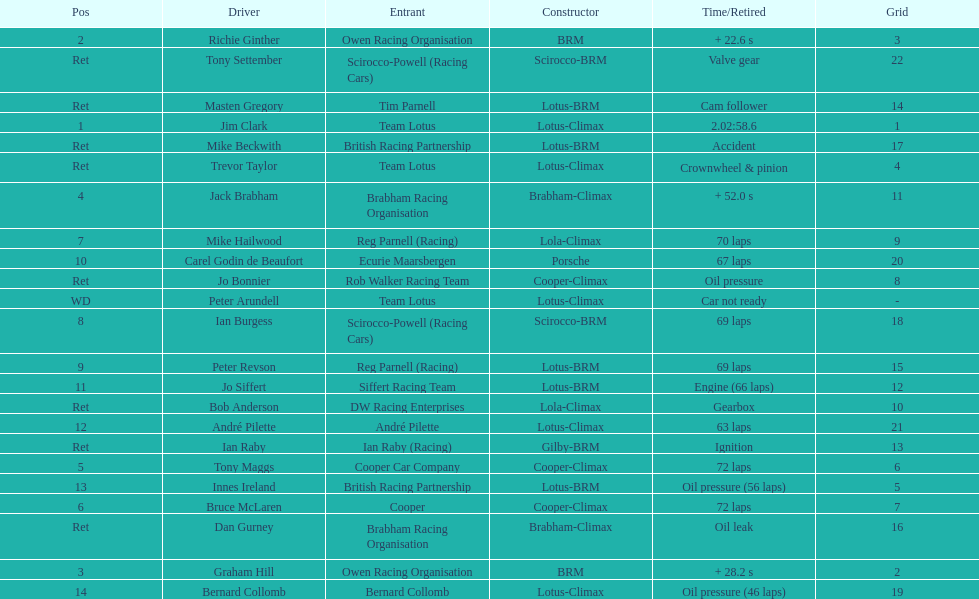Give me the full table as a dictionary. {'header': ['Pos', 'Driver', 'Entrant', 'Constructor', 'Time/Retired', 'Grid'], 'rows': [['2', 'Richie Ginther', 'Owen Racing Organisation', 'BRM', '+ 22.6 s', '3'], ['Ret', 'Tony Settember', 'Scirocco-Powell (Racing Cars)', 'Scirocco-BRM', 'Valve gear', '22'], ['Ret', 'Masten Gregory', 'Tim Parnell', 'Lotus-BRM', 'Cam follower', '14'], ['1', 'Jim Clark', 'Team Lotus', 'Lotus-Climax', '2.02:58.6', '1'], ['Ret', 'Mike Beckwith', 'British Racing Partnership', 'Lotus-BRM', 'Accident', '17'], ['Ret', 'Trevor Taylor', 'Team Lotus', 'Lotus-Climax', 'Crownwheel & pinion', '4'], ['4', 'Jack Brabham', 'Brabham Racing Organisation', 'Brabham-Climax', '+ 52.0 s', '11'], ['7', 'Mike Hailwood', 'Reg Parnell (Racing)', 'Lola-Climax', '70 laps', '9'], ['10', 'Carel Godin de Beaufort', 'Ecurie Maarsbergen', 'Porsche', '67 laps', '20'], ['Ret', 'Jo Bonnier', 'Rob Walker Racing Team', 'Cooper-Climax', 'Oil pressure', '8'], ['WD', 'Peter Arundell', 'Team Lotus', 'Lotus-Climax', 'Car not ready', '-'], ['8', 'Ian Burgess', 'Scirocco-Powell (Racing Cars)', 'Scirocco-BRM', '69 laps', '18'], ['9', 'Peter Revson', 'Reg Parnell (Racing)', 'Lotus-BRM', '69 laps', '15'], ['11', 'Jo Siffert', 'Siffert Racing Team', 'Lotus-BRM', 'Engine (66 laps)', '12'], ['Ret', 'Bob Anderson', 'DW Racing Enterprises', 'Lola-Climax', 'Gearbox', '10'], ['12', 'André Pilette', 'André Pilette', 'Lotus-Climax', '63 laps', '21'], ['Ret', 'Ian Raby', 'Ian Raby (Racing)', 'Gilby-BRM', 'Ignition', '13'], ['5', 'Tony Maggs', 'Cooper Car Company', 'Cooper-Climax', '72 laps', '6'], ['13', 'Innes Ireland', 'British Racing Partnership', 'Lotus-BRM', 'Oil pressure (56 laps)', '5'], ['6', 'Bruce McLaren', 'Cooper', 'Cooper-Climax', '72 laps', '7'], ['Ret', 'Dan Gurney', 'Brabham Racing Organisation', 'Brabham-Climax', 'Oil leak', '16'], ['3', 'Graham Hill', 'Owen Racing Organisation', 'BRM', '+ 28.2 s', '2'], ['14', 'Bernard Collomb', 'Bernard Collomb', 'Lotus-Climax', 'Oil pressure (46 laps)', '19']]} Who was the top finisher that drove a cooper-climax? Tony Maggs. 